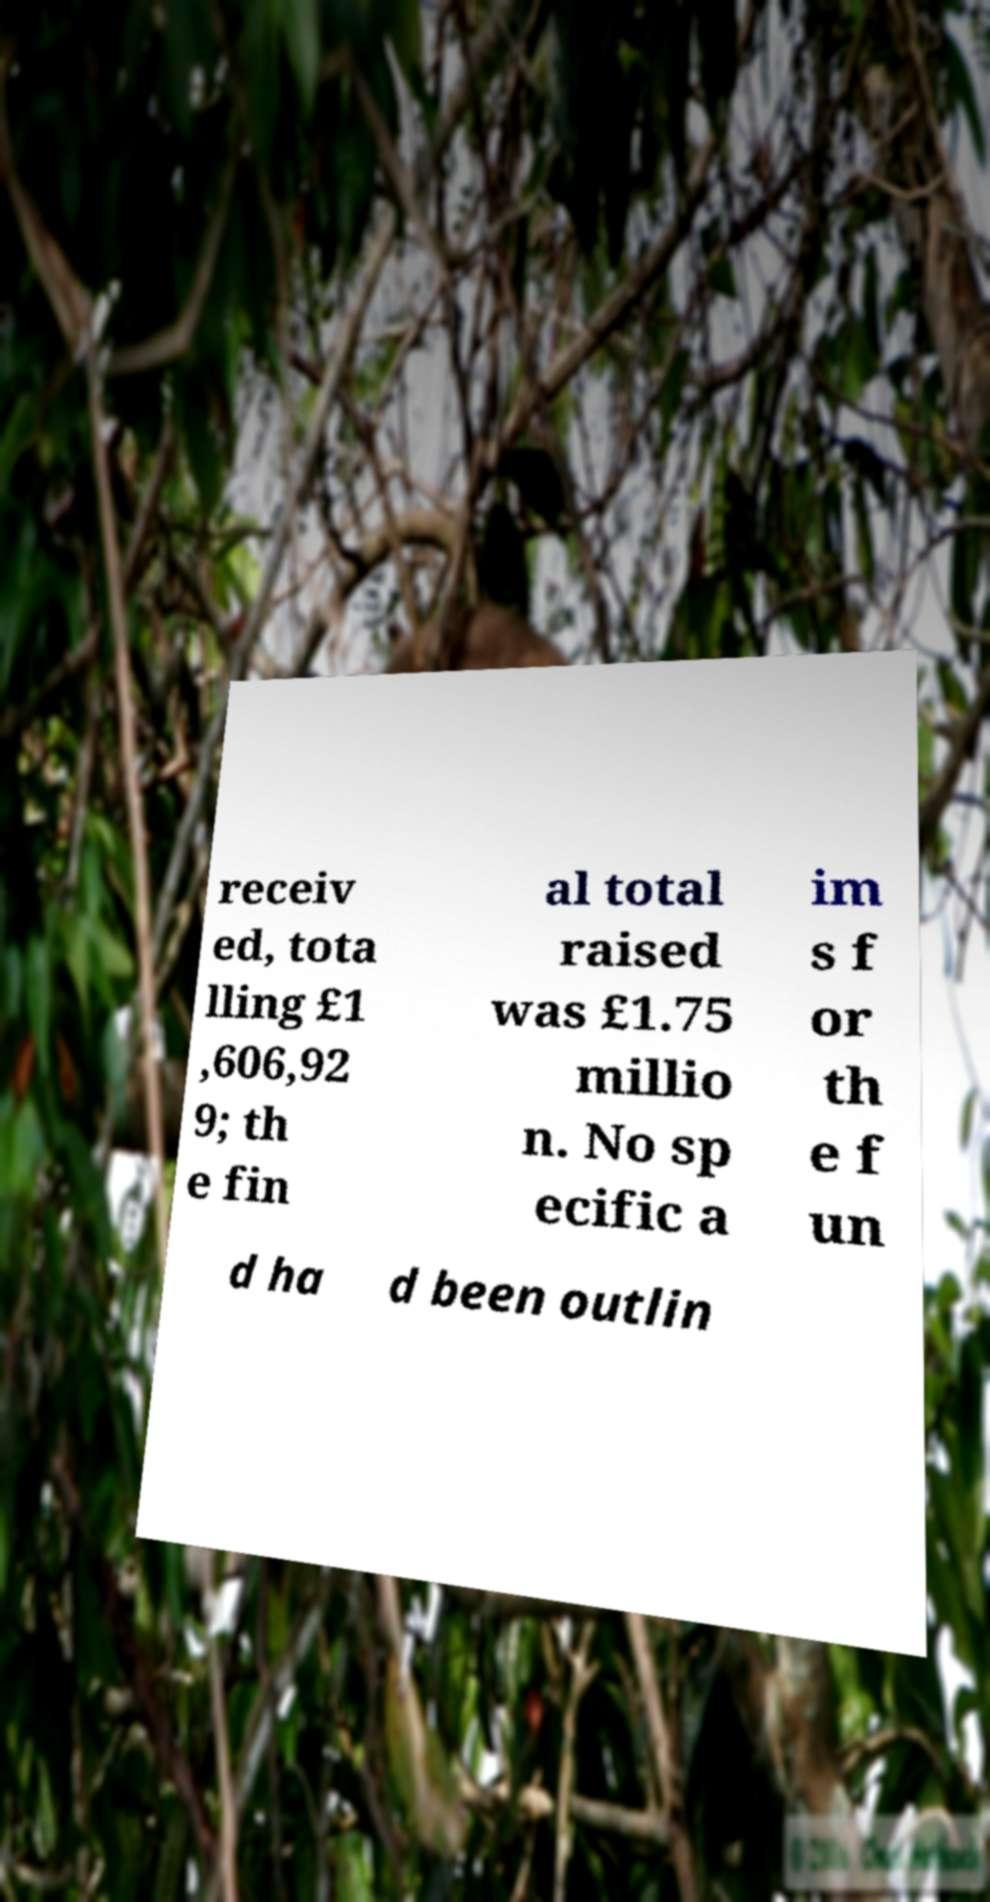Can you accurately transcribe the text from the provided image for me? receiv ed, tota lling £1 ,606,92 9; th e fin al total raised was £1.75 millio n. No sp ecific a im s f or th e f un d ha d been outlin 